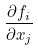Convert formula to latex. <formula><loc_0><loc_0><loc_500><loc_500>\frac { \partial f _ { i } } { \partial x _ { j } }</formula> 